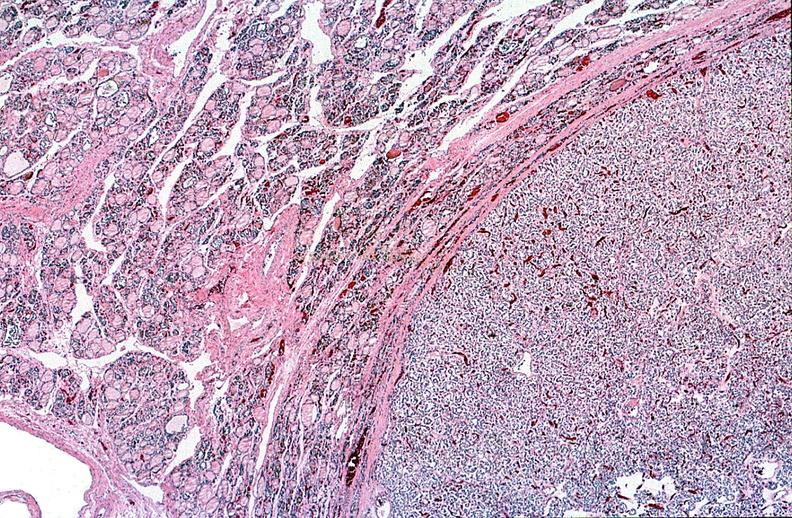what is present?
Answer the question using a single word or phrase. Endocrine 